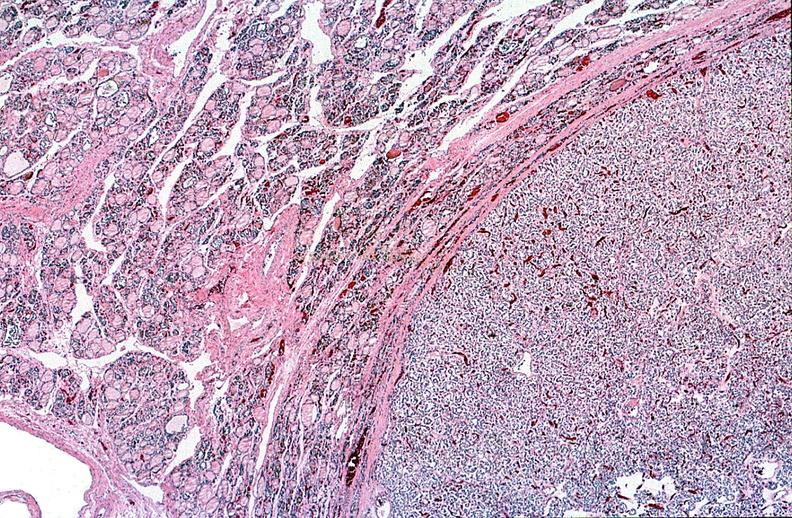what is present?
Answer the question using a single word or phrase. Endocrine 